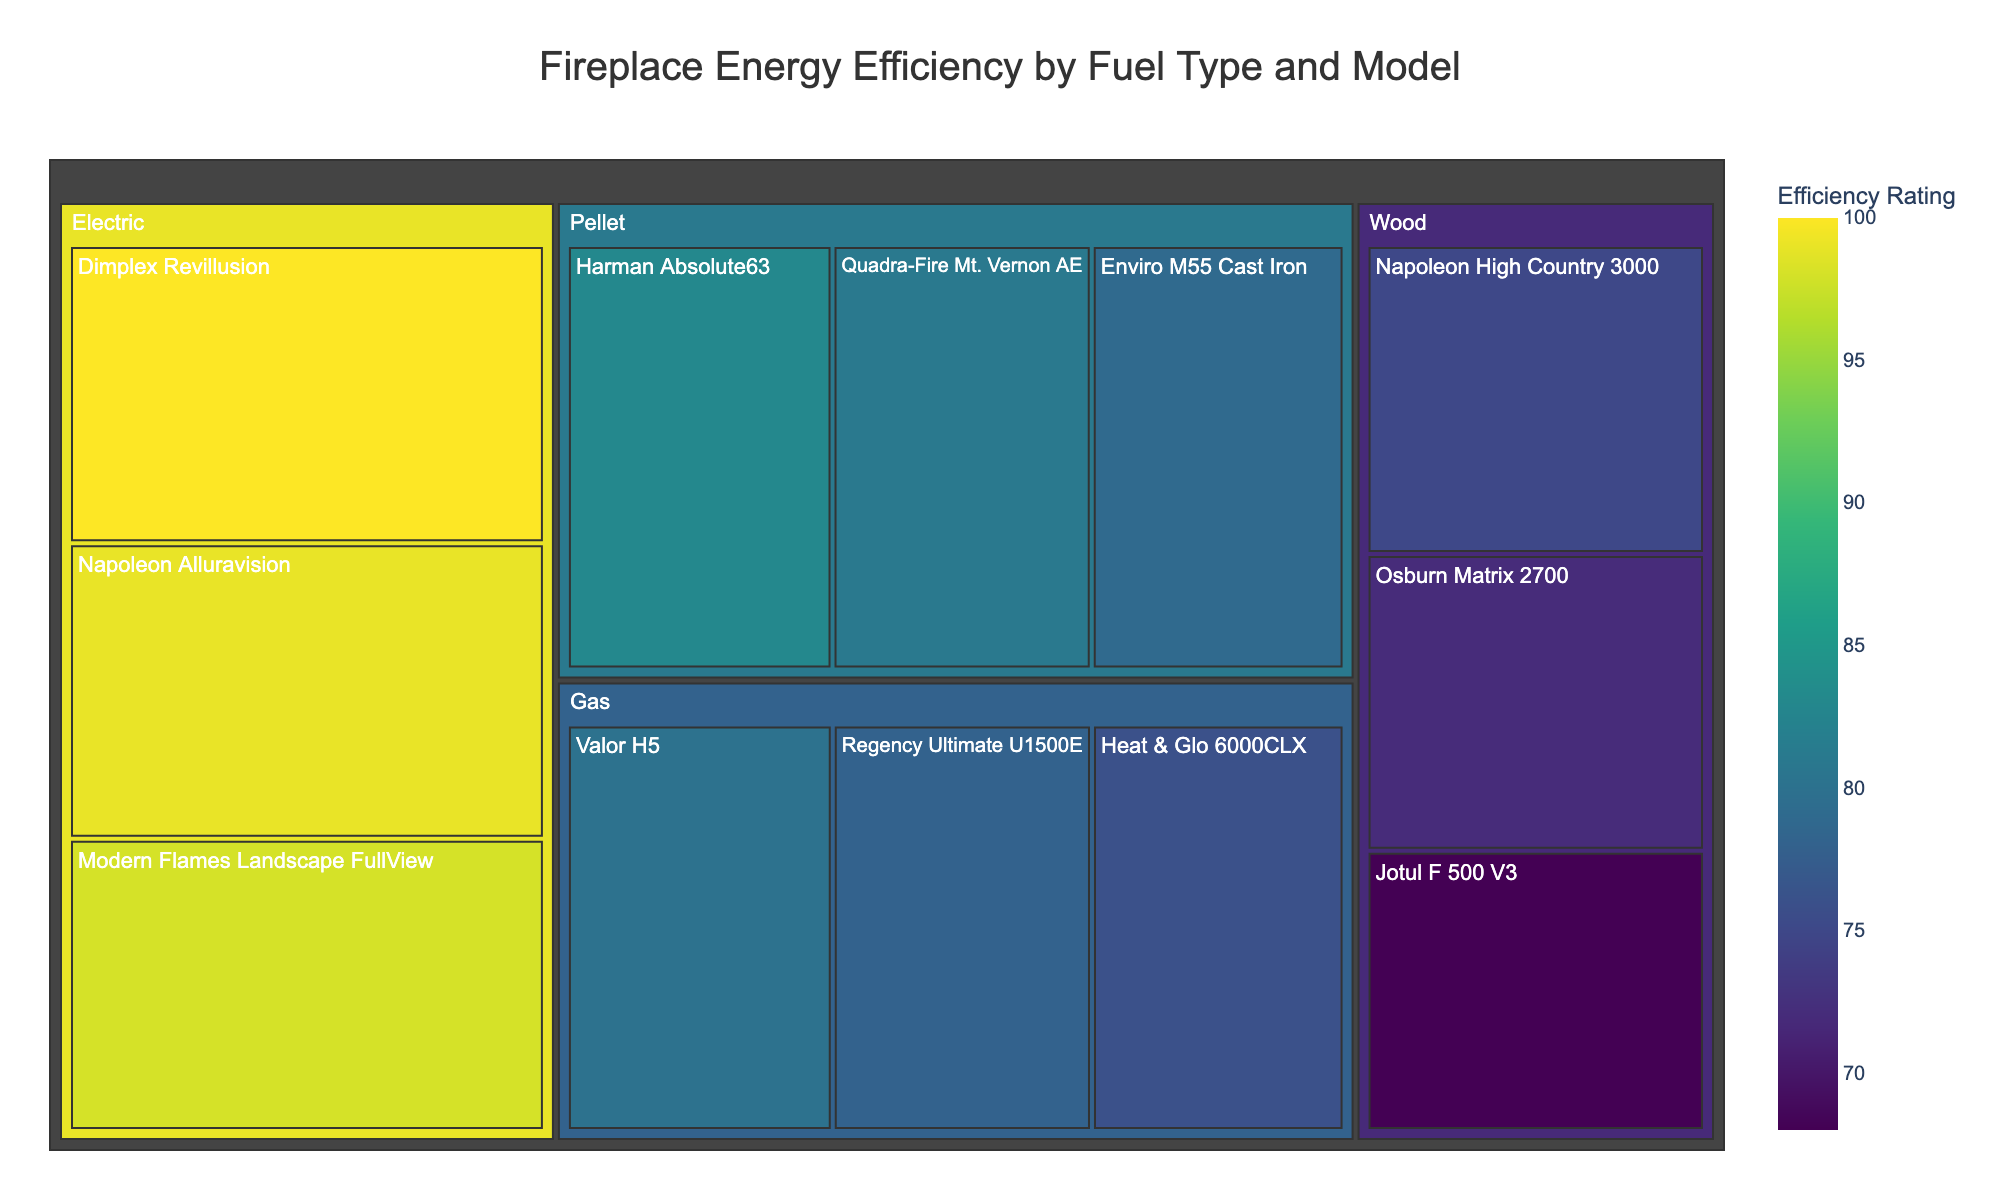What is the title of the treemap? The title is located at the top of the treemap, centered horizontally. To find the title, just read the text that is prominently displayed there.
Answer: Fireplace Energy Efficiency by Fuel Type and Model Which fuel type has the highest efficiency rating for any model? To find the fuel type with the highest efficiency, look for the largest value among the efficiency ratings. The highest rating is 100, which corresponds to an electric model.
Answer: Electric Which model has the lowest efficiency rating among wood fireplaces? Locate the wood category in the treemap and identify the model with the smallest efficiency rating within that group. The Jotul F 500 V3 has an efficiency rating of 68, which is the lowest.
Answer: Jotul F 500 V3 What is the average efficiency rating for pellet fireplaces? Identify the efficiency ratings of pellet models: Harman Absolute63 (83), Quadra-Fire Mt. Vernon AE (81), and Enviro M55 Cast Iron (79). Sum these up and divide by the number of models (3). (83 + 81 + 79) / 3 = 243 / 3 = 81
Answer: 81 Compare the highest efficiency rating of wood fireplaces to gas fireplaces. Which is higher and by how much? The highest efficiency rating for wood fireplaces is 75 (Napoleon High Country 3000), and for gas fireplaces is 80 (Valor H5). Subtract the higher value from the lower value to find the difference. 80 - 75 = 5.
Answer: Gas by 5% How many models of electric fireplaces are displayed in the treemap? Count the number of separate rectangles under the Electric category in the treemap. There are three models: Dimplex Revillusion, Napoleon Alluravision, Modern Flames Landscape FullView.
Answer: 3 Which fuel type has the most models listed? Look at each fuel type category and count the number of models listed. Wood and Pellet both have three models each. Compare the counts — Wood and Pellet are equal and have the highest count.
Answer: Wood and Pellet Is there a model with an efficiency rating of 100? If yes, what is the model and fuel type? Search the treemap for the efficiency rating of 100. It is under Electric fuel type and the model is Dimplex Revillusion.
Answer: Yes, Dimplex Revillusion, Electric 